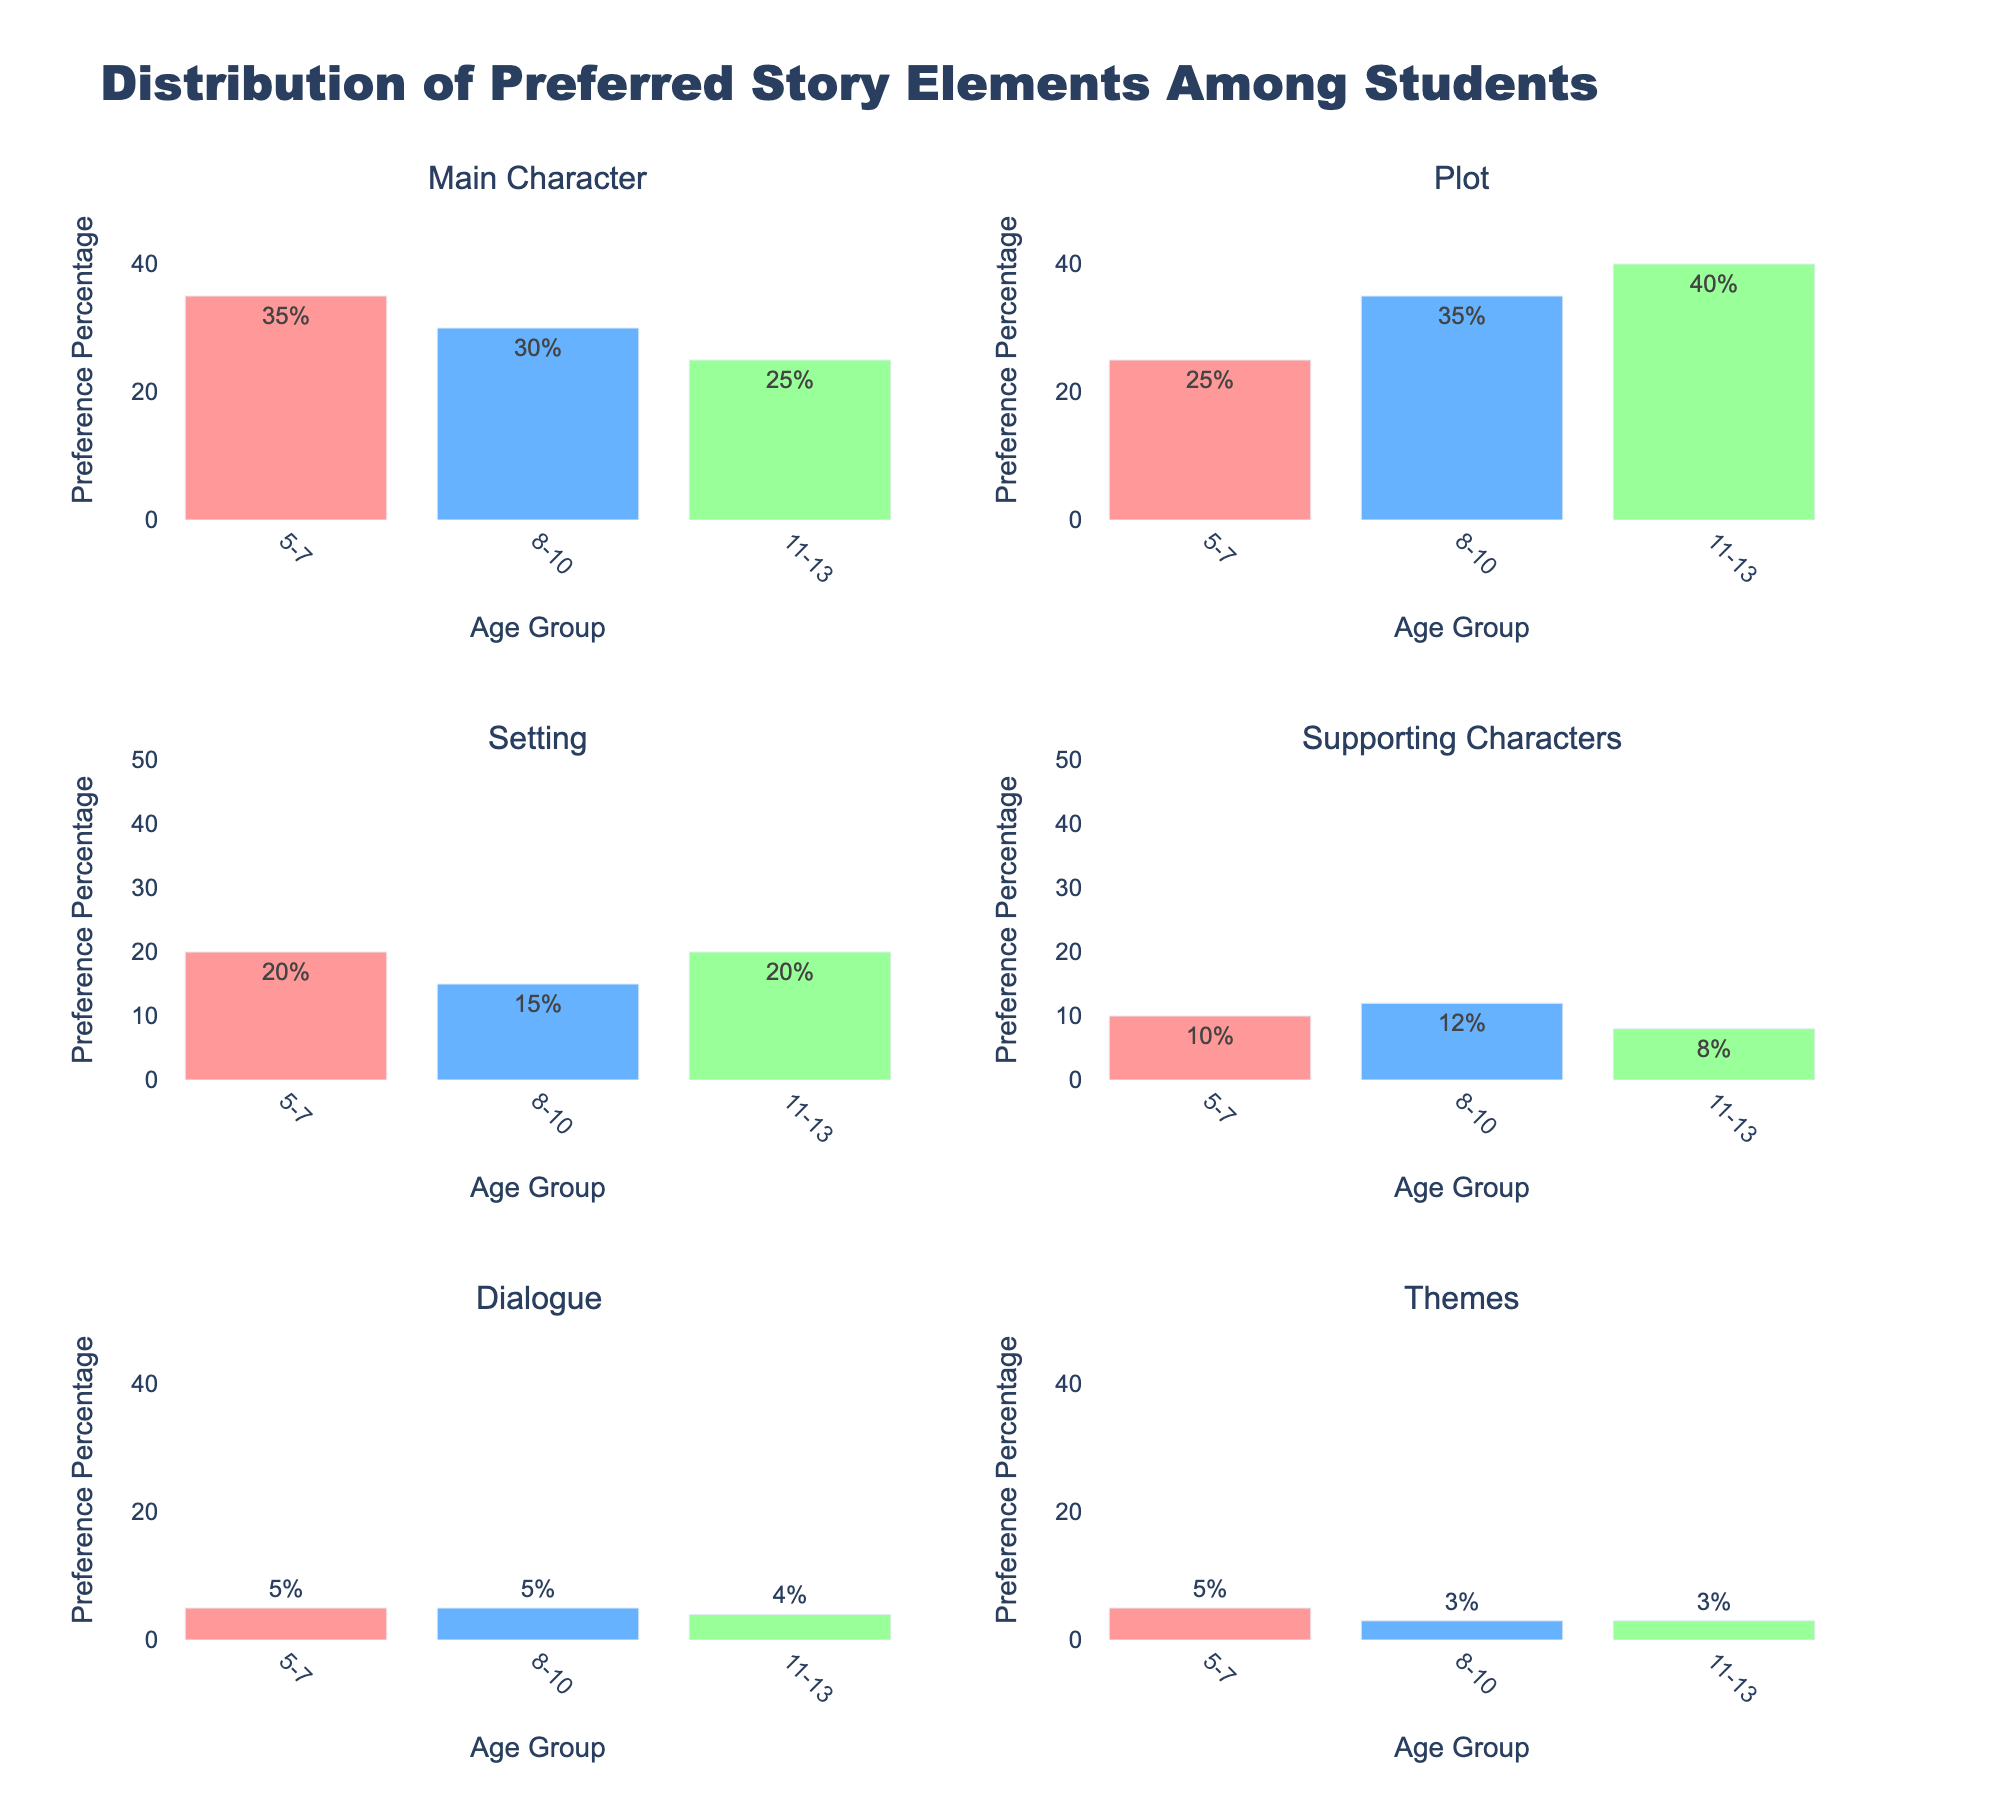what is the title of the figure? The title of the figure is located at the top of the plot. By reading the text in this area, we can determine the title.
Answer: Distribution of Preferred Story Elements Among Students Which age group has the highest preference for the "Plot" story element? To identify the age group with the highest preference for the "Plot" story element, look at the "Plot" subplot and compare the heights of the bars across the age groups. The highest bar indicates the highest preference percentage.
Answer: 11-13 How does the preference for "Main Character" change across age groups? To examine how the preference for "Main Character" changes, look at the bar heights in the "Main Character" subplot and observe how they increase or decrease across age groups (5-7, 8-10, 11-13).
Answer: It decreases from 5-7 to 11-13 What is the combined preference percentage for "Supporting Characters" and "Dialogue" in the 5-7 age group? To find the combined preference, sum the preference percentages of "Supporting Characters" and "Dialogue" for the 5-7 age group by adding the heights of the corresponding bars in each subplot.
Answer: 15% How does the preference for "Setting" in the 5-7 age group compare to the 8-10 age group? Compare the heights of the bars representing 5-7 and 8-10 age groups within the "Setting" subplot. The height difference will indicate how the preference changes.
Answer: Higher in 5-7 Which story element has the least preference among 11-13-year-olds? To find the story element with the least preference, check the bar heights corresponding to the 11-13 age group across all subplots and identify the shortest bar.
Answer: Themes What is the average preference percentage for the "Main Character" across all age groups? To calculate the average preference percentage, add the preference percentages for the "Main Character" across all age groups and divide by the number of age groups: (35 + 30 + 25) / 3.
Answer: 30% Does any age group have a preference for "Themes" over 5%? Look at the "Themes" subplot and check the bars for all age groups to see if any of them exceed the 5% mark.
Answer: No Which story element shows the most significant increase in preference as the age group increases from 5-7 to 11-13? Check the increase in bar heights from 5-7 to 11-13 in each subplot and identify the story element with the largest growth.
Answer: Plot How does the preference for "Supporting Characters" change with age? Evaluate the bar heights for "Supporting Characters" across the age groups (5-7, 8-10, 11-13) to see if they increase, decrease, or remain constant.
Answer: It decreases from 5-7 to 11-13 